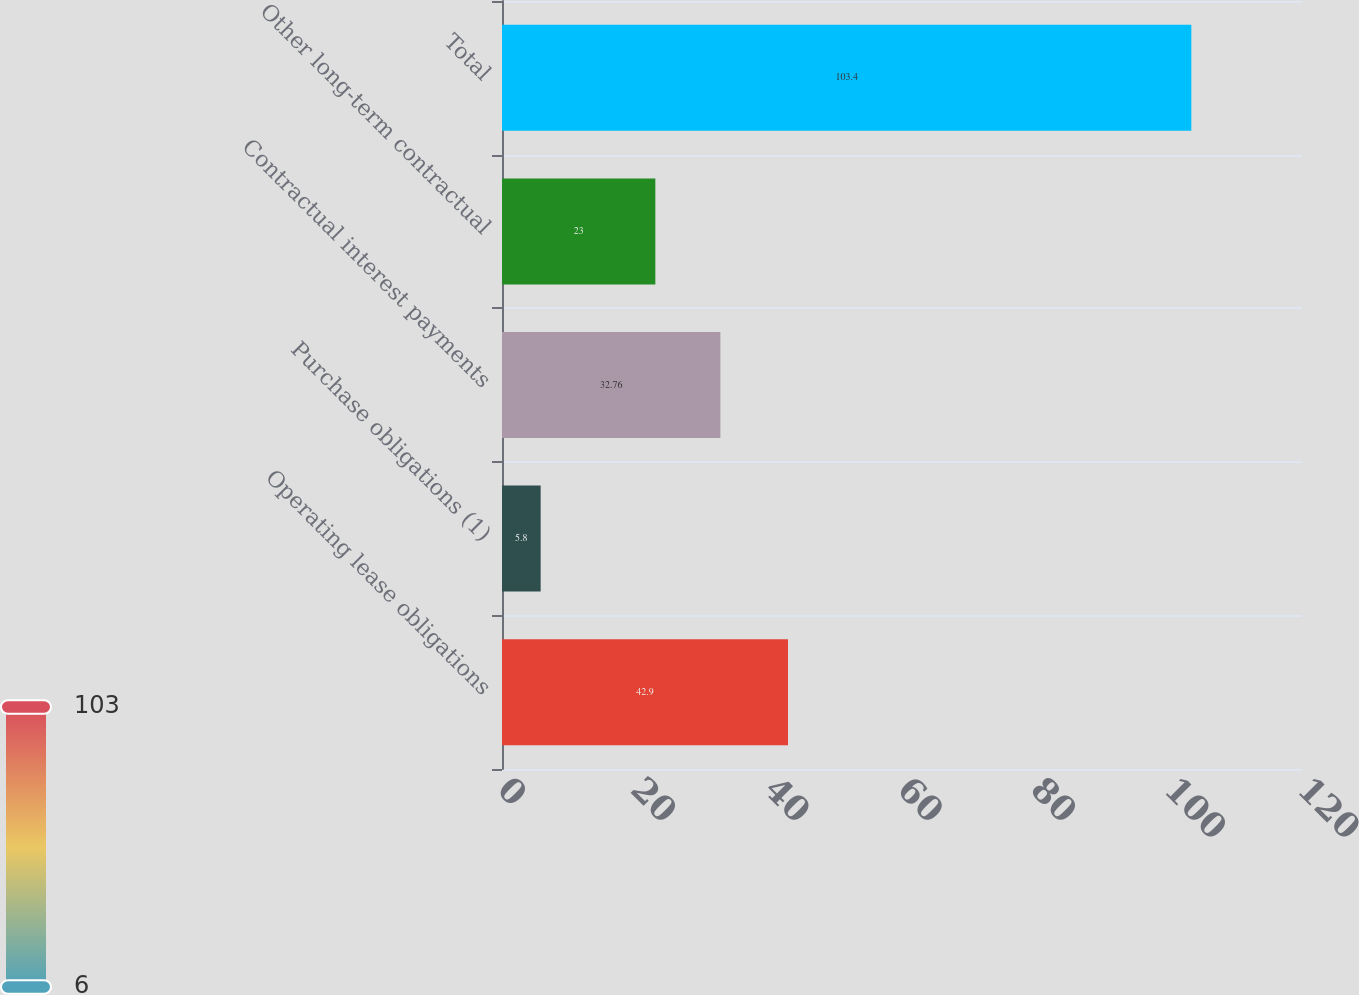Convert chart to OTSL. <chart><loc_0><loc_0><loc_500><loc_500><bar_chart><fcel>Operating lease obligations<fcel>Purchase obligations (1)<fcel>Contractual interest payments<fcel>Other long-term contractual<fcel>Total<nl><fcel>42.9<fcel>5.8<fcel>32.76<fcel>23<fcel>103.4<nl></chart> 